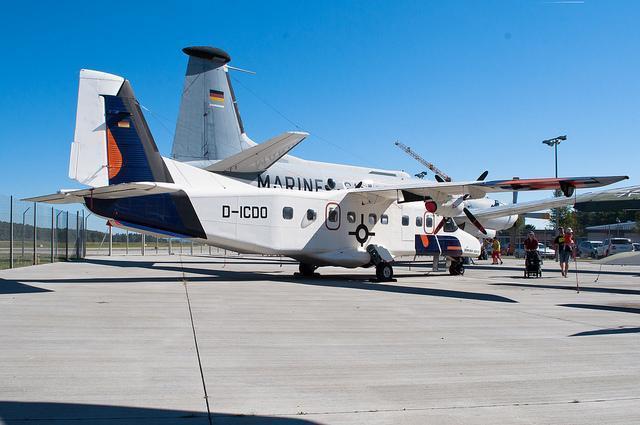What top speed can this vehicle likely reach?
Answer the question by selecting the correct answer among the 4 following choices.
Options: 80000 mph, 500000mph, 7000 mph, 1000 mph. 1000 mph. 